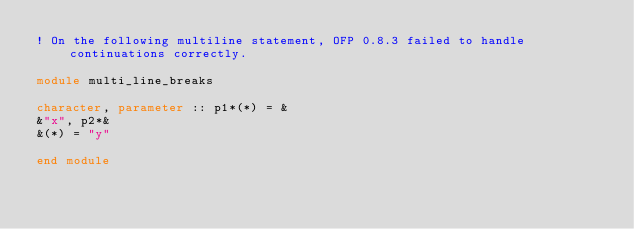Convert code to text. <code><loc_0><loc_0><loc_500><loc_500><_FORTRAN_>! On the following multiline statement, OFP 0.8.3 failed to handle continuations correctly.

module multi_line_breaks

character, parameter :: p1*(*) = &
&"x", p2*&
&(*) = "y"

end module
</code> 